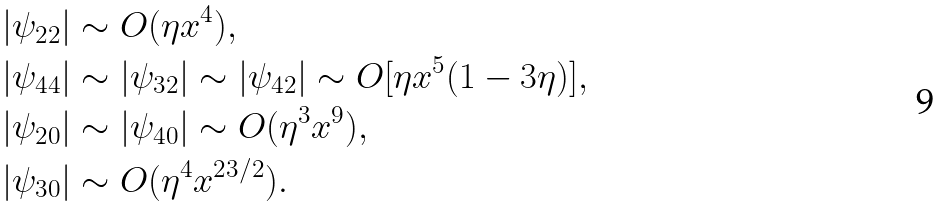<formula> <loc_0><loc_0><loc_500><loc_500>& | \psi _ { 2 2 } | \sim O ( \eta x ^ { 4 } ) , \\ & | \psi _ { 4 4 } | \sim | \psi _ { 3 2 } | \sim | \psi _ { 4 2 } | \sim O [ \eta x ^ { 5 } ( 1 - 3 \eta ) ] , \\ & | \psi _ { 2 0 } | \sim | \psi _ { 4 0 } | \sim O ( \eta ^ { 3 } x ^ { 9 } ) , \\ & | \psi _ { 3 0 } | \sim O ( \eta ^ { 4 } x ^ { 2 3 / 2 } ) .</formula> 